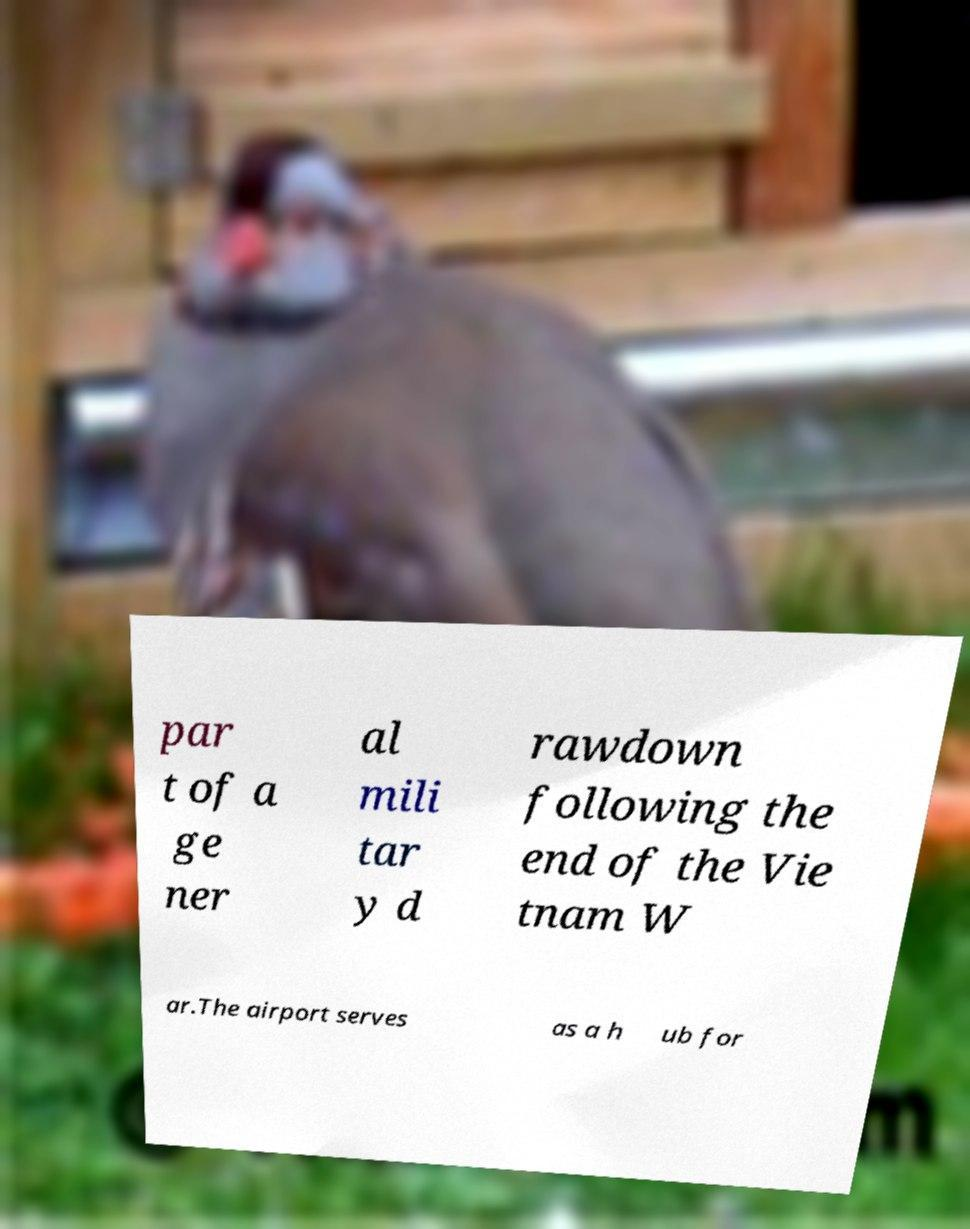I need the written content from this picture converted into text. Can you do that? par t of a ge ner al mili tar y d rawdown following the end of the Vie tnam W ar.The airport serves as a h ub for 